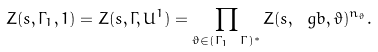<formula> <loc_0><loc_0><loc_500><loc_500>Z ( s , \Gamma _ { 1 } , 1 ) = Z ( s , \Gamma , U ^ { 1 } ) = \prod _ { \vartheta \in ( \Gamma _ { 1 } \ \Gamma ) ^ { * } } Z ( s , \ g b , \vartheta ) ^ { n _ { \vartheta } } .</formula> 